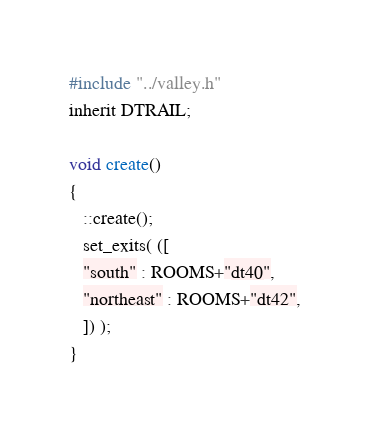<code> <loc_0><loc_0><loc_500><loc_500><_C_>#include "../valley.h"
inherit DTRAIL;

void create()
{
   ::create();
   set_exits( ([
   "south" : ROOMS+"dt40",
   "northeast" : ROOMS+"dt42",
   ]) );
}
</code> 